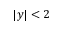<formula> <loc_0><loc_0><loc_500><loc_500>| y | < 2</formula> 